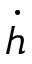<formula> <loc_0><loc_0><loc_500><loc_500>\dot { h }</formula> 